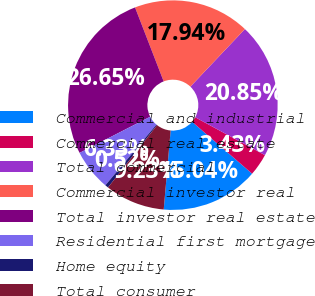Convert chart to OTSL. <chart><loc_0><loc_0><loc_500><loc_500><pie_chart><fcel>Commercial and industrial<fcel>Commercial real estate<fcel>Total commercial<fcel>Commercial investor real<fcel>Total investor real estate<fcel>Residential first mortgage<fcel>Home equity<fcel>Total consumer<nl><fcel>15.04%<fcel>3.43%<fcel>20.85%<fcel>17.94%<fcel>26.65%<fcel>6.33%<fcel>0.52%<fcel>9.23%<nl></chart> 